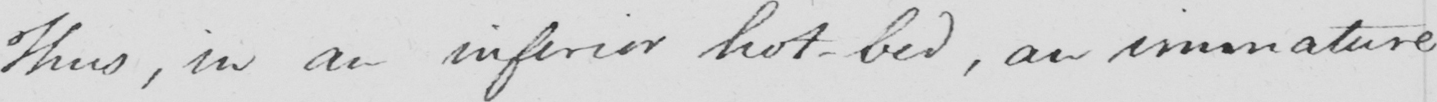Can you read and transcribe this handwriting? Thus , in an inferior hot-bed , an immature 